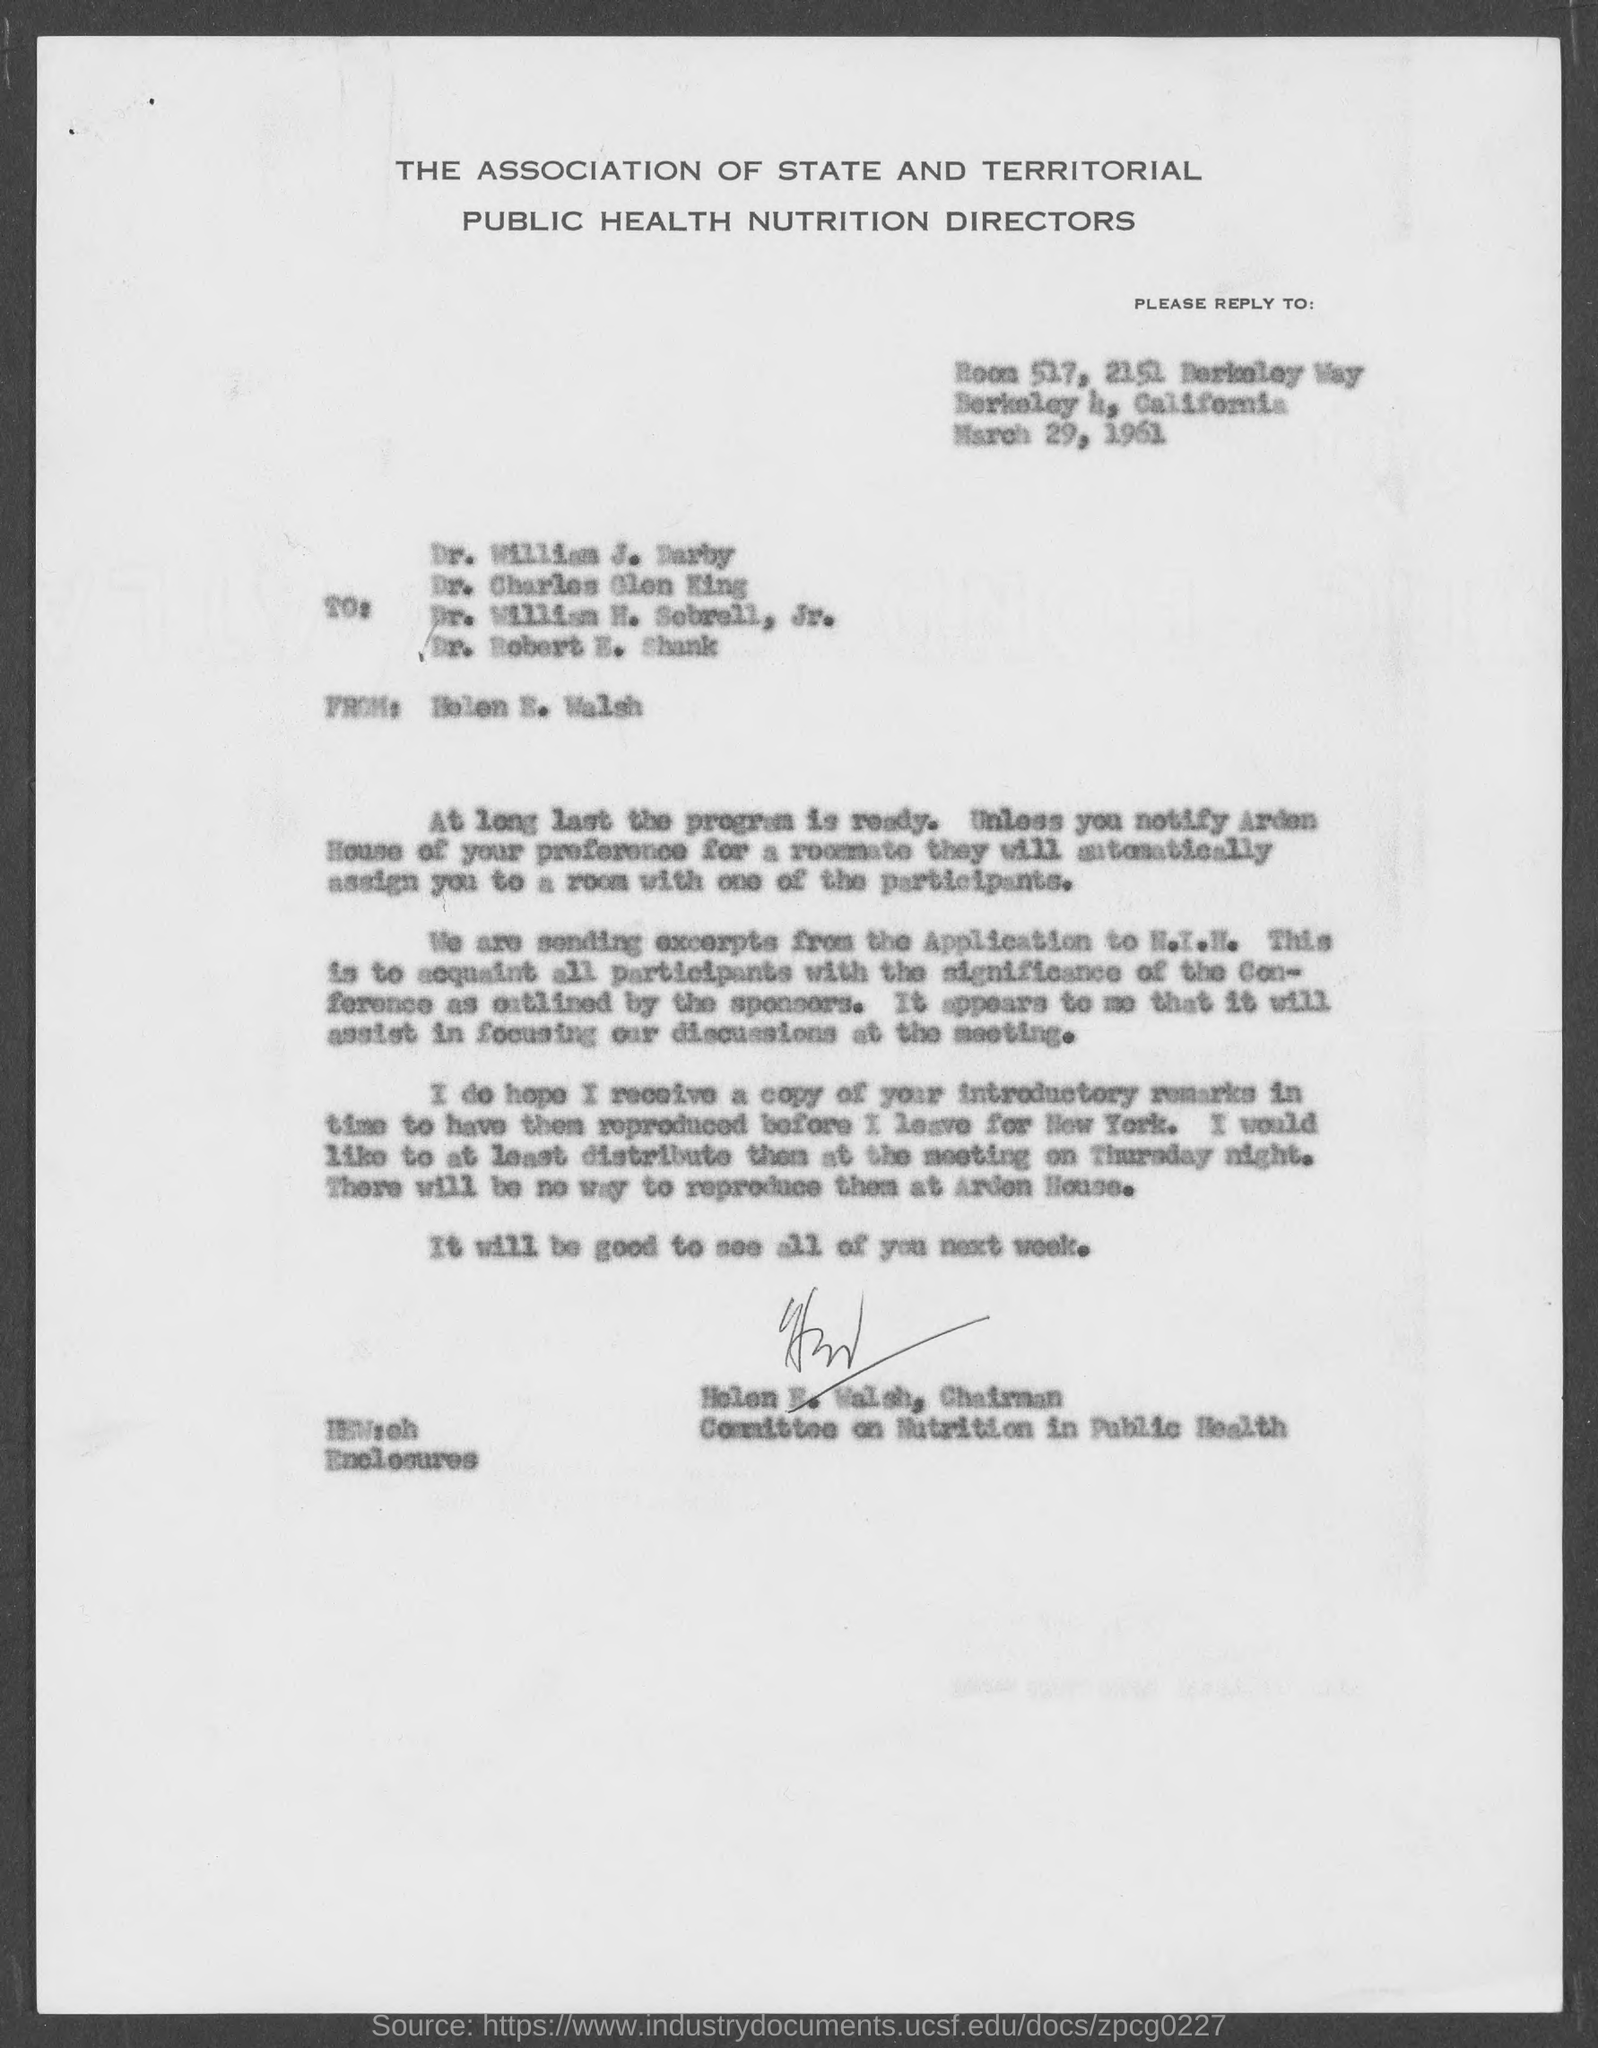Point out several critical features in this image. Helen E is the chairman of the Committee on Nutrition in Public Health. The first recipient is Dr. William J. Darby. The letter was sent by Helen E. Walsh. The letter was sent on March 29, 1961. The Association of State and Territorial Public Health Nutrition Directors is a named entity that refers to a specific group or organization. 